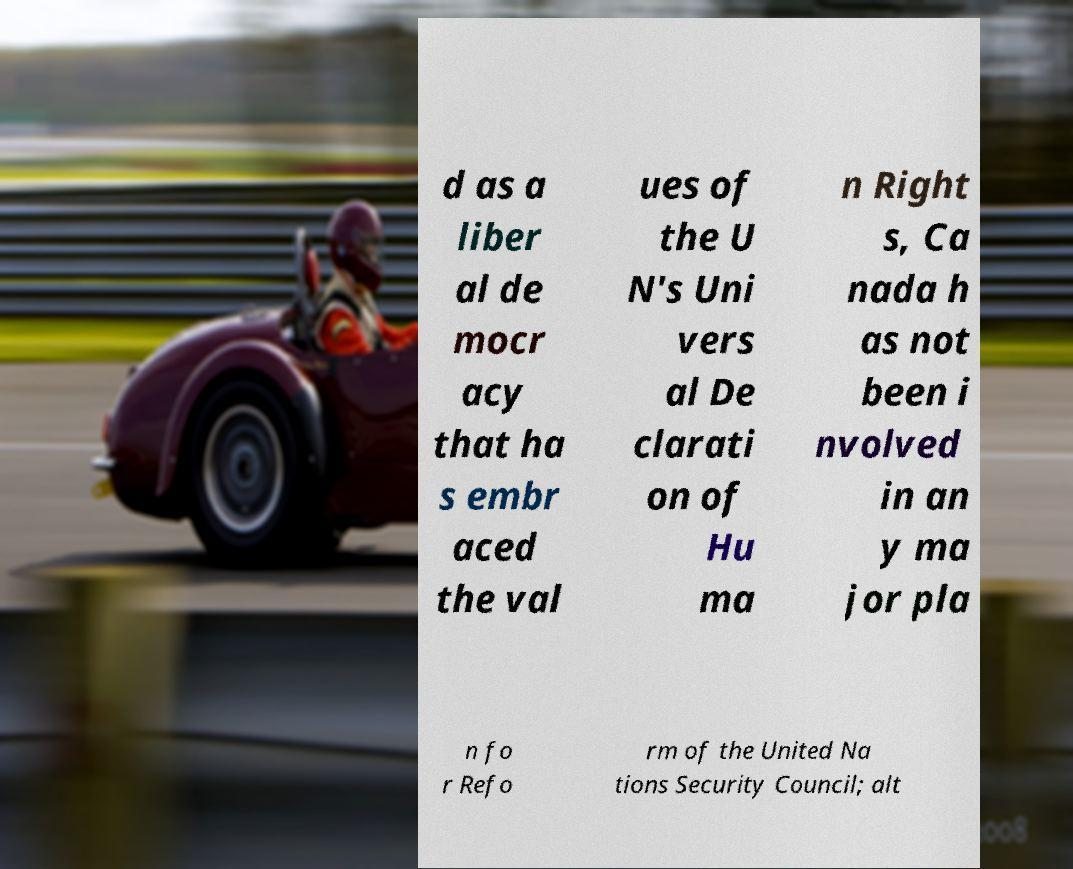Can you accurately transcribe the text from the provided image for me? d as a liber al de mocr acy that ha s embr aced the val ues of the U N's Uni vers al De clarati on of Hu ma n Right s, Ca nada h as not been i nvolved in an y ma jor pla n fo r Refo rm of the United Na tions Security Council; alt 